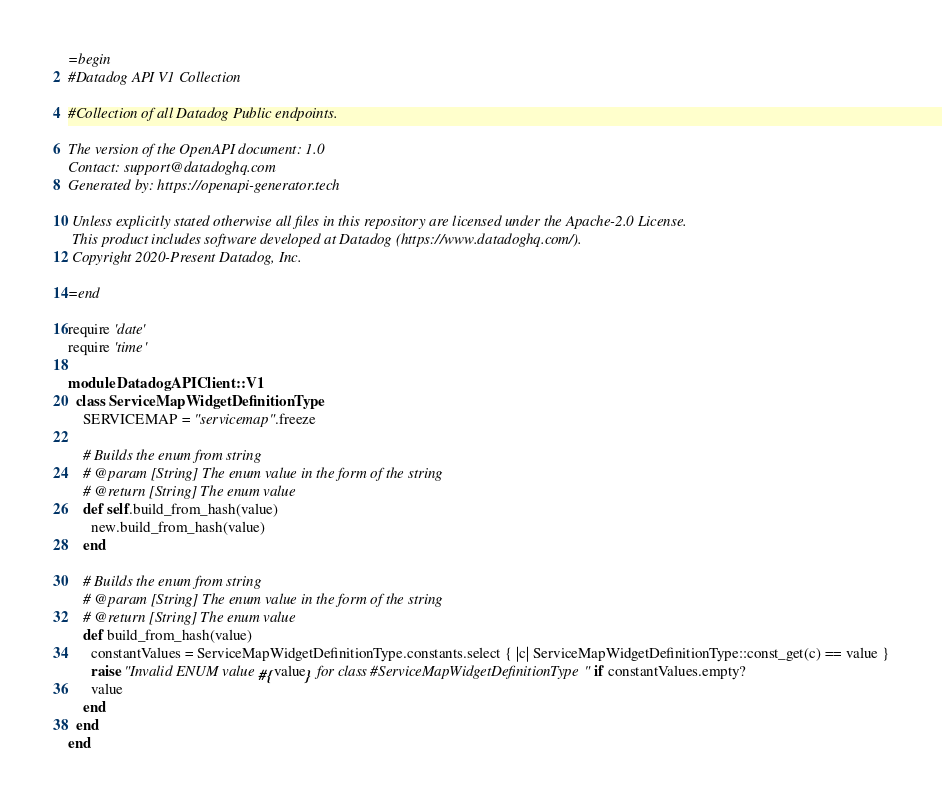<code> <loc_0><loc_0><loc_500><loc_500><_Ruby_>=begin
#Datadog API V1 Collection

#Collection of all Datadog Public endpoints.

The version of the OpenAPI document: 1.0
Contact: support@datadoghq.com
Generated by: https://openapi-generator.tech

 Unless explicitly stated otherwise all files in this repository are licensed under the Apache-2.0 License.
 This product includes software developed at Datadog (https://www.datadoghq.com/).
 Copyright 2020-Present Datadog, Inc.

=end

require 'date'
require 'time'

module DatadogAPIClient::V1
  class ServiceMapWidgetDefinitionType
    SERVICEMAP = "servicemap".freeze

    # Builds the enum from string
    # @param [String] The enum value in the form of the string
    # @return [String] The enum value
    def self.build_from_hash(value)
      new.build_from_hash(value)
    end

    # Builds the enum from string
    # @param [String] The enum value in the form of the string
    # @return [String] The enum value
    def build_from_hash(value)
      constantValues = ServiceMapWidgetDefinitionType.constants.select { |c| ServiceMapWidgetDefinitionType::const_get(c) == value }
      raise "Invalid ENUM value #{value} for class #ServiceMapWidgetDefinitionType" if constantValues.empty?
      value
    end
  end
end
</code> 